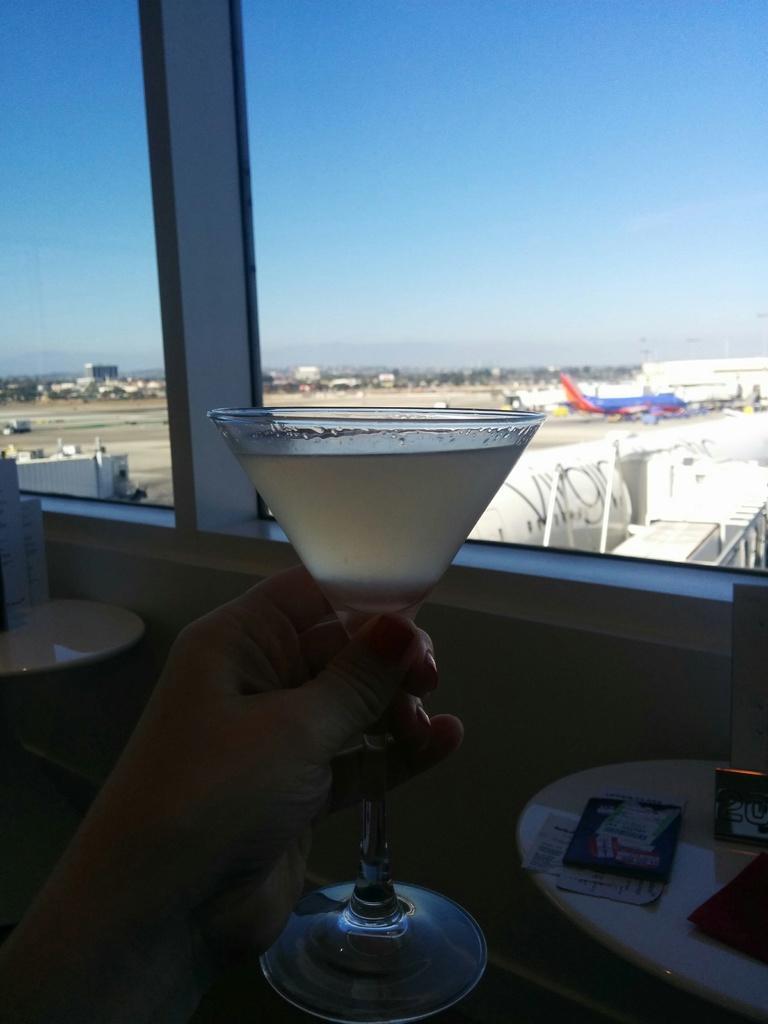Describe this image in one or two sentences. In this picture we can see a person's hand is holding a glass, tables with papers, some objects on it and front the glass we can see an airplane on the ground, some objects and the sky. 